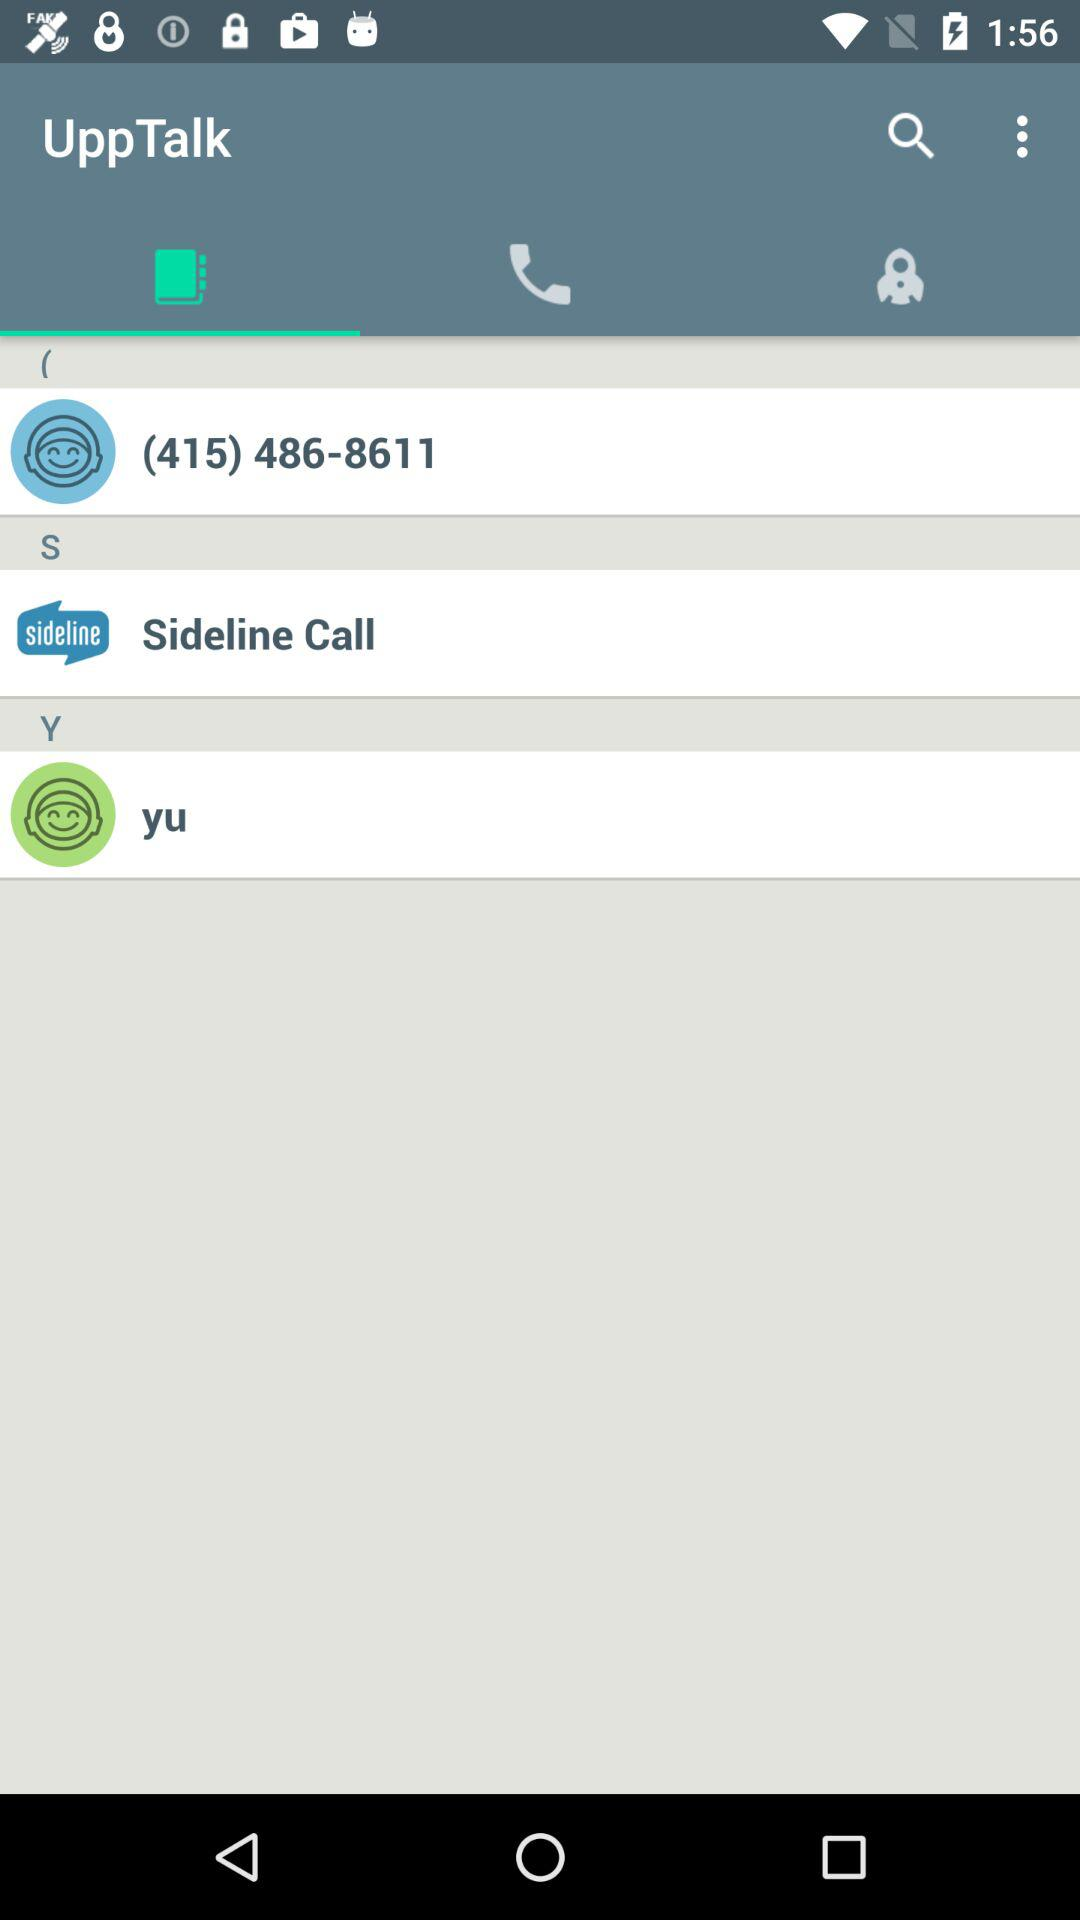What is the given phone number in "UppTalk"? The given phone number is (415) 486-8611. 